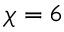<formula> <loc_0><loc_0><loc_500><loc_500>\chi = 6</formula> 